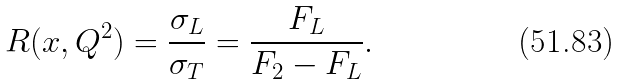Convert formula to latex. <formula><loc_0><loc_0><loc_500><loc_500>R ( x , Q ^ { 2 } ) = \frac { \sigma _ { L } } { \sigma _ { T } } = \frac { F _ { L } } { F _ { 2 } - F _ { L } } .</formula> 